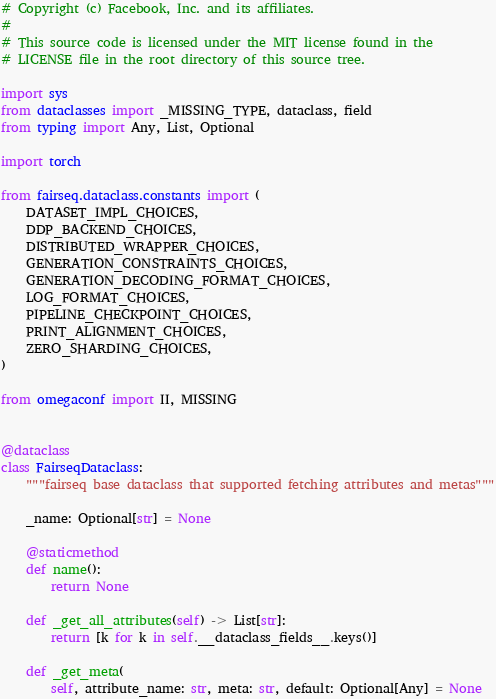Convert code to text. <code><loc_0><loc_0><loc_500><loc_500><_Python_># Copyright (c) Facebook, Inc. and its affiliates.
#
# This source code is licensed under the MIT license found in the
# LICENSE file in the root directory of this source tree.

import sys
from dataclasses import _MISSING_TYPE, dataclass, field
from typing import Any, List, Optional

import torch

from fairseq.dataclass.constants import (
    DATASET_IMPL_CHOICES,
    DDP_BACKEND_CHOICES,
    DISTRIBUTED_WRAPPER_CHOICES,
    GENERATION_CONSTRAINTS_CHOICES,
    GENERATION_DECODING_FORMAT_CHOICES,
    LOG_FORMAT_CHOICES,
    PIPELINE_CHECKPOINT_CHOICES,
    PRINT_ALIGNMENT_CHOICES,
    ZERO_SHARDING_CHOICES,
)

from omegaconf import II, MISSING


@dataclass
class FairseqDataclass:
    """fairseq base dataclass that supported fetching attributes and metas"""

    _name: Optional[str] = None

    @staticmethod
    def name():
        return None

    def _get_all_attributes(self) -> List[str]:
        return [k for k in self.__dataclass_fields__.keys()]

    def _get_meta(
        self, attribute_name: str, meta: str, default: Optional[Any] = None</code> 